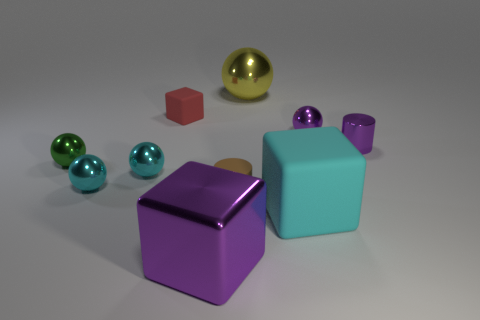Subtract all large shiny balls. How many balls are left? 4 Subtract all purple cylinders. How many cylinders are left? 1 Subtract all blocks. How many objects are left? 7 Subtract 2 cubes. How many cubes are left? 1 Subtract all brown cylinders. How many green spheres are left? 1 Add 9 tiny brown objects. How many tiny brown objects are left? 10 Add 8 large matte objects. How many large matte objects exist? 9 Subtract 1 yellow balls. How many objects are left? 9 Subtract all red blocks. Subtract all red cylinders. How many blocks are left? 2 Subtract all green metallic balls. Subtract all cubes. How many objects are left? 6 